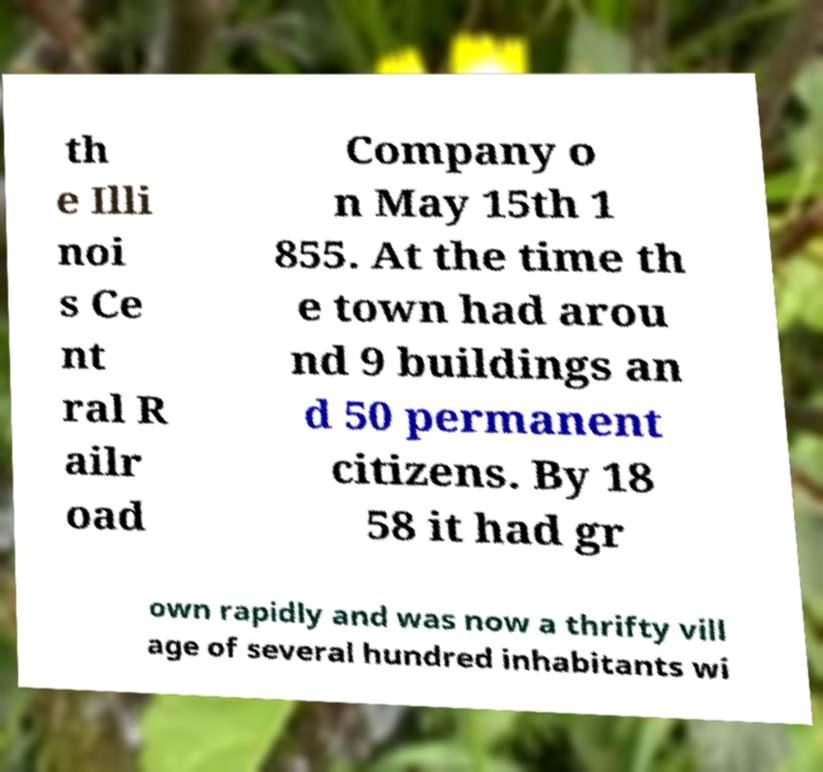For documentation purposes, I need the text within this image transcribed. Could you provide that? th e Illi noi s Ce nt ral R ailr oad Company o n May 15th 1 855. At the time th e town had arou nd 9 buildings an d 50 permanent citizens. By 18 58 it had gr own rapidly and was now a thrifty vill age of several hundred inhabitants wi 